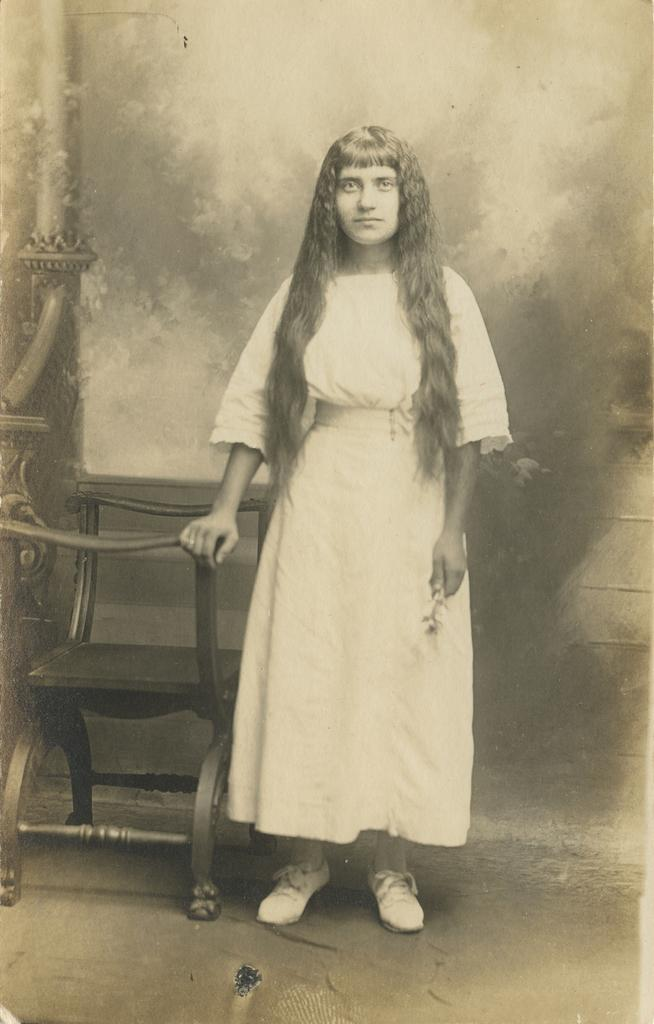What is the main subject of the image? The main subject of the image is a woman. What is the woman doing in the image? The woman is standing in the image. What object is the woman holding in the image? The woman is holding a chair with her hand. What type of square-shaped goat can be seen reading a book in the image? There is no goat or book present in the image, and therefore no such activity can be observed. 